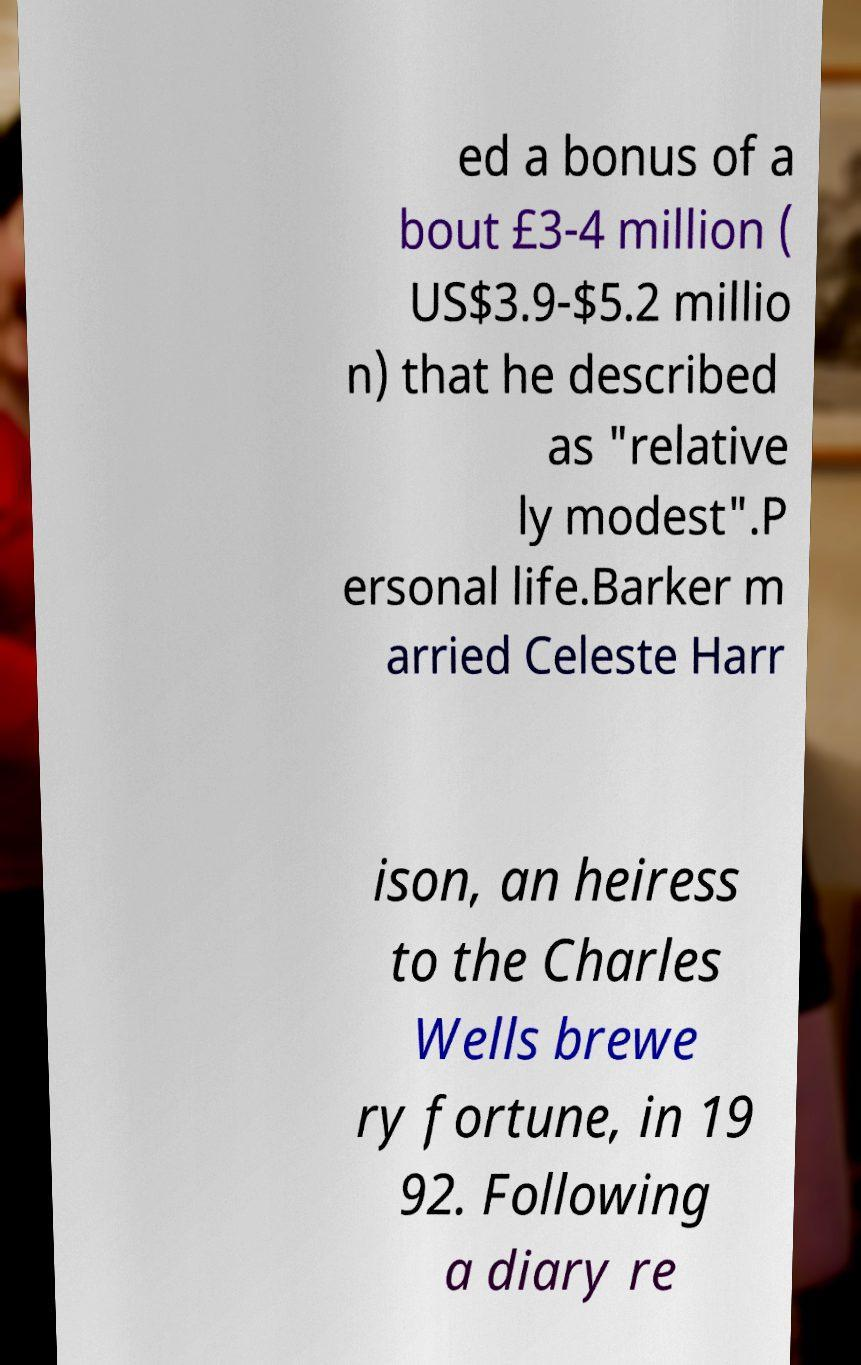Please identify and transcribe the text found in this image. ed a bonus of a bout £3-4 million ( US$3.9-$5.2 millio n) that he described as "relative ly modest".P ersonal life.Barker m arried Celeste Harr ison, an heiress to the Charles Wells brewe ry fortune, in 19 92. Following a diary re 